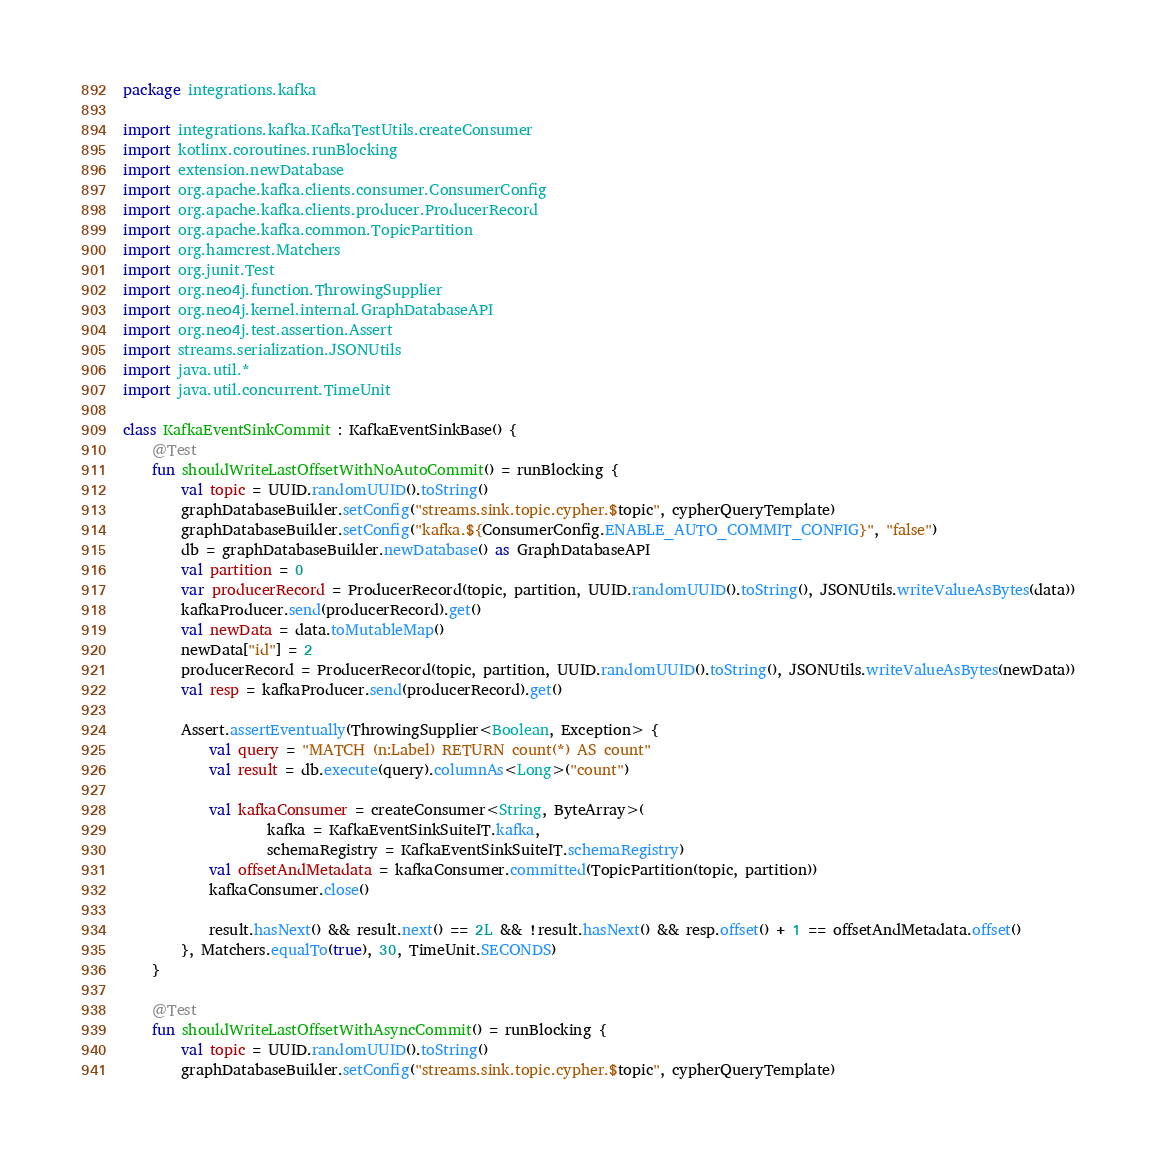<code> <loc_0><loc_0><loc_500><loc_500><_Kotlin_>package integrations.kafka

import integrations.kafka.KafkaTestUtils.createConsumer
import kotlinx.coroutines.runBlocking
import extension.newDatabase
import org.apache.kafka.clients.consumer.ConsumerConfig
import org.apache.kafka.clients.producer.ProducerRecord
import org.apache.kafka.common.TopicPartition
import org.hamcrest.Matchers
import org.junit.Test
import org.neo4j.function.ThrowingSupplier
import org.neo4j.kernel.internal.GraphDatabaseAPI
import org.neo4j.test.assertion.Assert
import streams.serialization.JSONUtils
import java.util.*
import java.util.concurrent.TimeUnit

class KafkaEventSinkCommit : KafkaEventSinkBase() {
    @Test
    fun shouldWriteLastOffsetWithNoAutoCommit() = runBlocking {
        val topic = UUID.randomUUID().toString()
        graphDatabaseBuilder.setConfig("streams.sink.topic.cypher.$topic", cypherQueryTemplate)
        graphDatabaseBuilder.setConfig("kafka.${ConsumerConfig.ENABLE_AUTO_COMMIT_CONFIG}", "false")
        db = graphDatabaseBuilder.newDatabase() as GraphDatabaseAPI
        val partition = 0
        var producerRecord = ProducerRecord(topic, partition, UUID.randomUUID().toString(), JSONUtils.writeValueAsBytes(data))
        kafkaProducer.send(producerRecord).get()
        val newData = data.toMutableMap()
        newData["id"] = 2
        producerRecord = ProducerRecord(topic, partition, UUID.randomUUID().toString(), JSONUtils.writeValueAsBytes(newData))
        val resp = kafkaProducer.send(producerRecord).get()

        Assert.assertEventually(ThrowingSupplier<Boolean, Exception> {
            val query = "MATCH (n:Label) RETURN count(*) AS count"
            val result = db.execute(query).columnAs<Long>("count")

            val kafkaConsumer = createConsumer<String, ByteArray>(
                    kafka = KafkaEventSinkSuiteIT.kafka,
                    schemaRegistry = KafkaEventSinkSuiteIT.schemaRegistry)
            val offsetAndMetadata = kafkaConsumer.committed(TopicPartition(topic, partition))
            kafkaConsumer.close()

            result.hasNext() && result.next() == 2L && !result.hasNext() && resp.offset() + 1 == offsetAndMetadata.offset()
        }, Matchers.equalTo(true), 30, TimeUnit.SECONDS)
    }

    @Test
    fun shouldWriteLastOffsetWithAsyncCommit() = runBlocking {
        val topic = UUID.randomUUID().toString()
        graphDatabaseBuilder.setConfig("streams.sink.topic.cypher.$topic", cypherQueryTemplate)</code> 